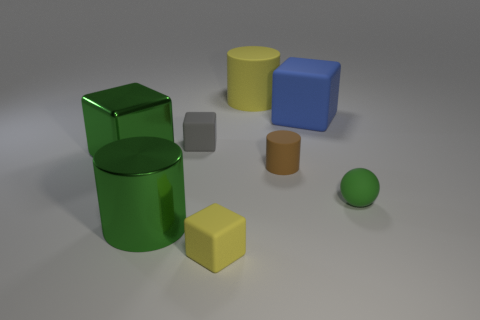Subtract all yellow blocks. How many blocks are left? 3 Subtract all spheres. How many objects are left? 7 Add 1 brown cylinders. How many objects exist? 9 Subtract all yellow cylinders. How many cylinders are left? 2 Subtract 3 cylinders. How many cylinders are left? 0 Subtract all cyan cylinders. Subtract all purple blocks. How many cylinders are left? 3 Subtract all gray cubes. How many purple spheres are left? 0 Subtract all red metal objects. Subtract all big blue matte things. How many objects are left? 7 Add 5 green things. How many green things are left? 8 Add 4 large cyan cylinders. How many large cyan cylinders exist? 4 